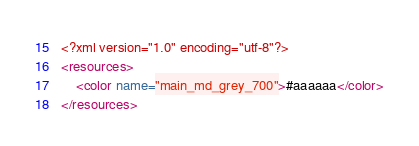Convert code to text. <code><loc_0><loc_0><loc_500><loc_500><_XML_><?xml version="1.0" encoding="utf-8"?>
<resources>
    <color name="main_md_grey_700">#aaaaaa</color>
</resources></code> 